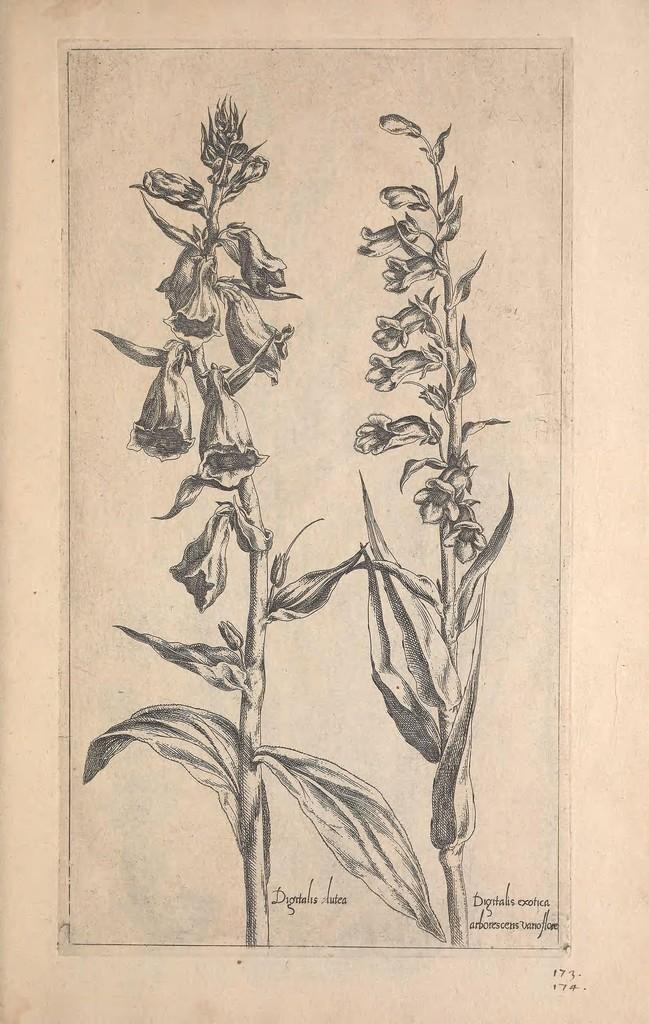What is the main subject of the image? There is a poster in the image. What is depicted on the poster? The poster features a flower and its plant. How many flower plants are visible in the image? There are two flower plants in the image. What is the color scheme of the image? The image is in black and white color. What historical event is being judged by the flower in the image? There is no historical event or judge present in the image; it features a poster with a flower and its plant in black and white. 